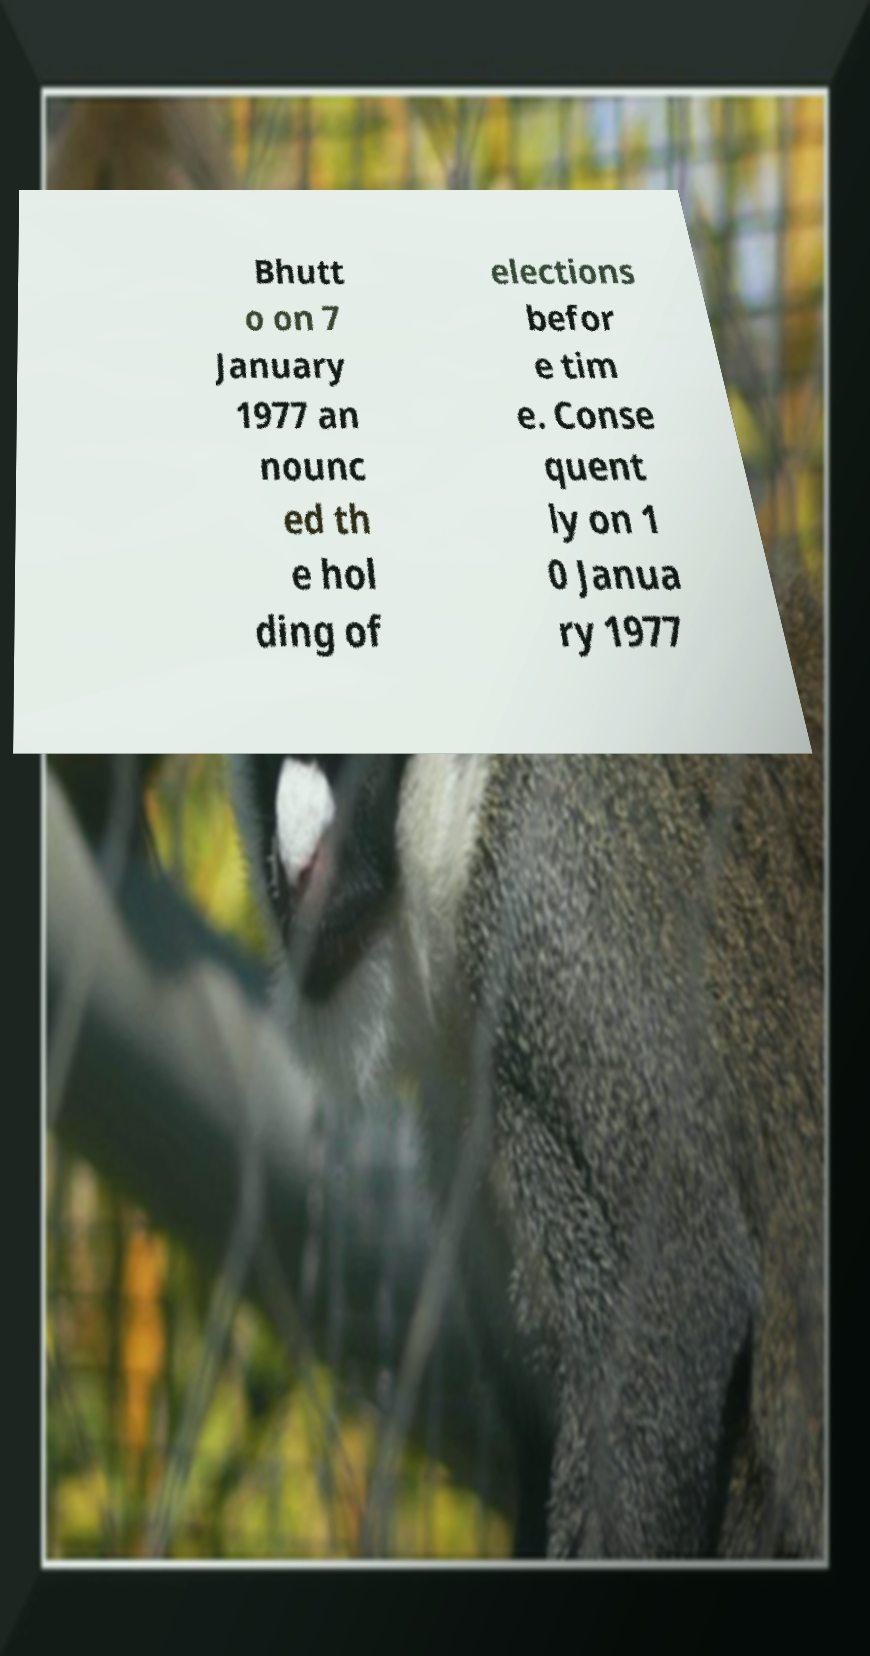Can you read and provide the text displayed in the image?This photo seems to have some interesting text. Can you extract and type it out for me? Bhutt o on 7 January 1977 an nounc ed th e hol ding of elections befor e tim e. Conse quent ly on 1 0 Janua ry 1977 